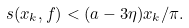Convert formula to latex. <formula><loc_0><loc_0><loc_500><loc_500>s ( x _ { k } , f ) < ( a - 3 \eta ) x _ { k } / \pi .</formula> 